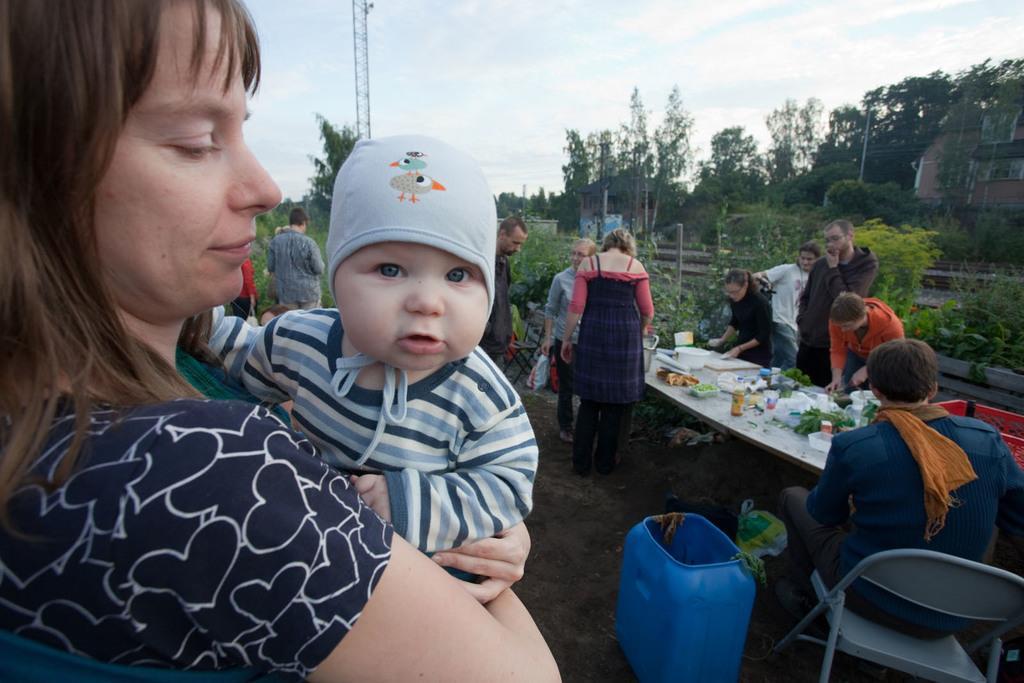In one or two sentences, can you explain what this image depicts? As we can see in the image there is a sky, current pole, trees, railway track and few people standing and sitting here and there and there is a chair and table. On table there are glasses, bowls and spoons. 